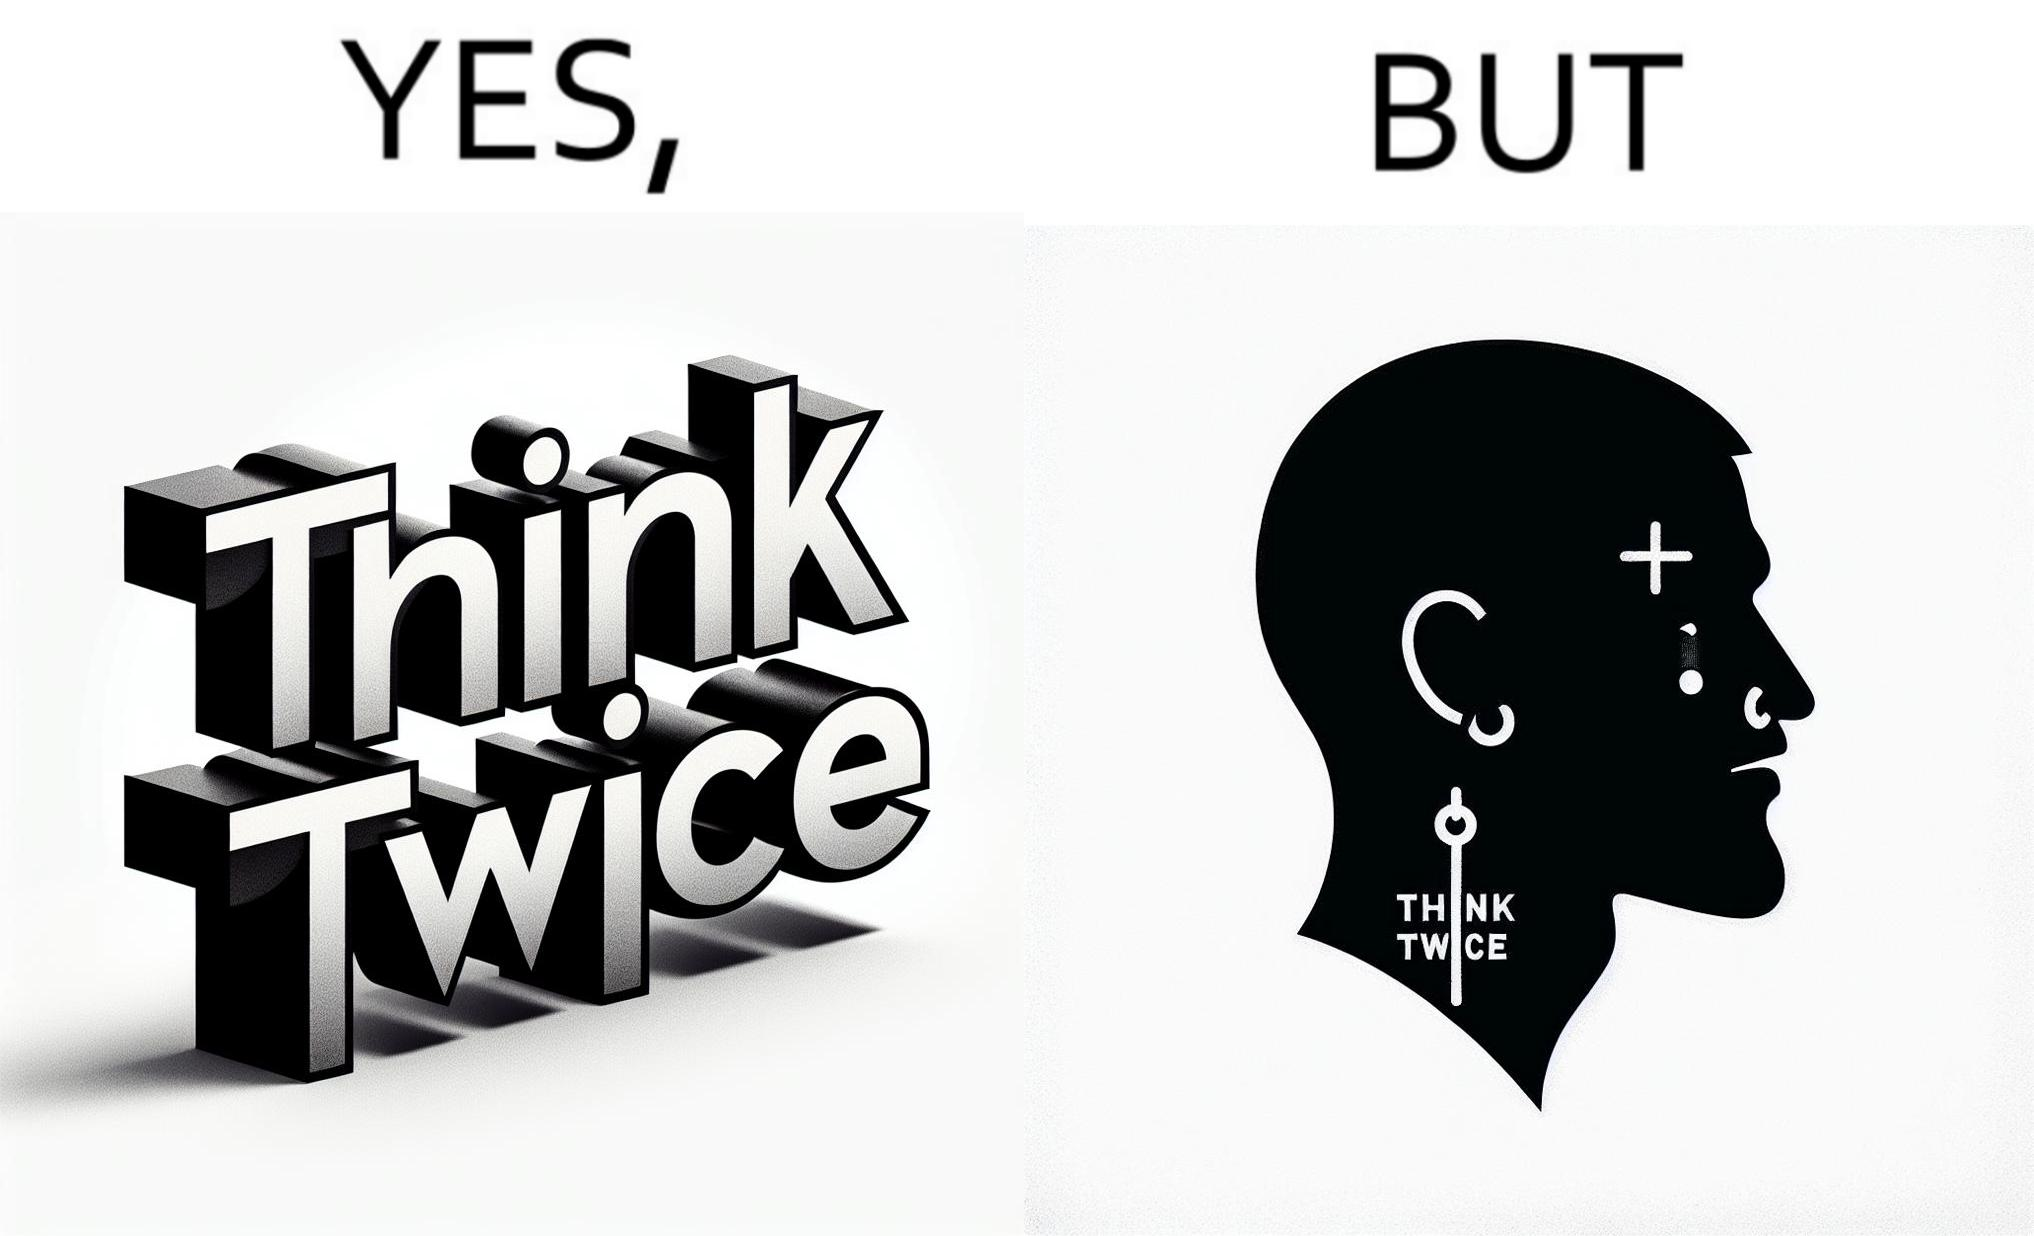What is shown in the left half versus the right half of this image? In the left part of the image: The image shows a text in english saying "Think Twice". The font seems very fashionable. In the right part of the image: The image shows the face of a man with a tattoo on the left side of a forehead saying "Think Twice". The man is wearing a nose ring and has a cut on his left eyebrow. He also has a small tattoo of the cross a little below his left eye. 